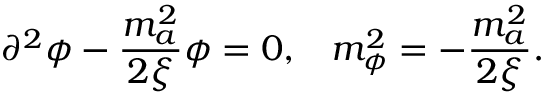<formula> <loc_0><loc_0><loc_500><loc_500>\partial ^ { 2 } \phi - { \frac { m _ { a } ^ { 2 } } { 2 \xi } } \phi = 0 , \, m _ { \phi } ^ { 2 } = - { \frac { m _ { a } ^ { 2 } } { 2 \xi } } .</formula> 